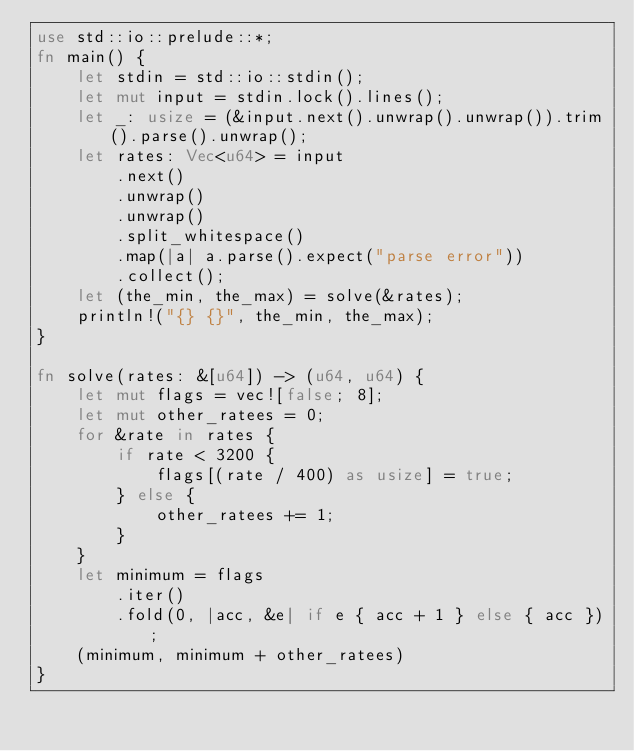<code> <loc_0><loc_0><loc_500><loc_500><_Rust_>use std::io::prelude::*;
fn main() {
    let stdin = std::io::stdin();
    let mut input = stdin.lock().lines();
    let _: usize = (&input.next().unwrap().unwrap()).trim().parse().unwrap();
    let rates: Vec<u64> = input
        .next()
        .unwrap()
        .unwrap()
        .split_whitespace()
        .map(|a| a.parse().expect("parse error"))
        .collect();
    let (the_min, the_max) = solve(&rates);
    println!("{} {}", the_min, the_max);
}

fn solve(rates: &[u64]) -> (u64, u64) {
    let mut flags = vec![false; 8];
    let mut other_ratees = 0;
    for &rate in rates {
        if rate < 3200 {
            flags[(rate / 400) as usize] = true;
        } else {
            other_ratees += 1;
        }
    }
    let minimum = flags
        .iter()
        .fold(0, |acc, &e| if e { acc + 1 } else { acc });
    (minimum, minimum + other_ratees)
}
</code> 